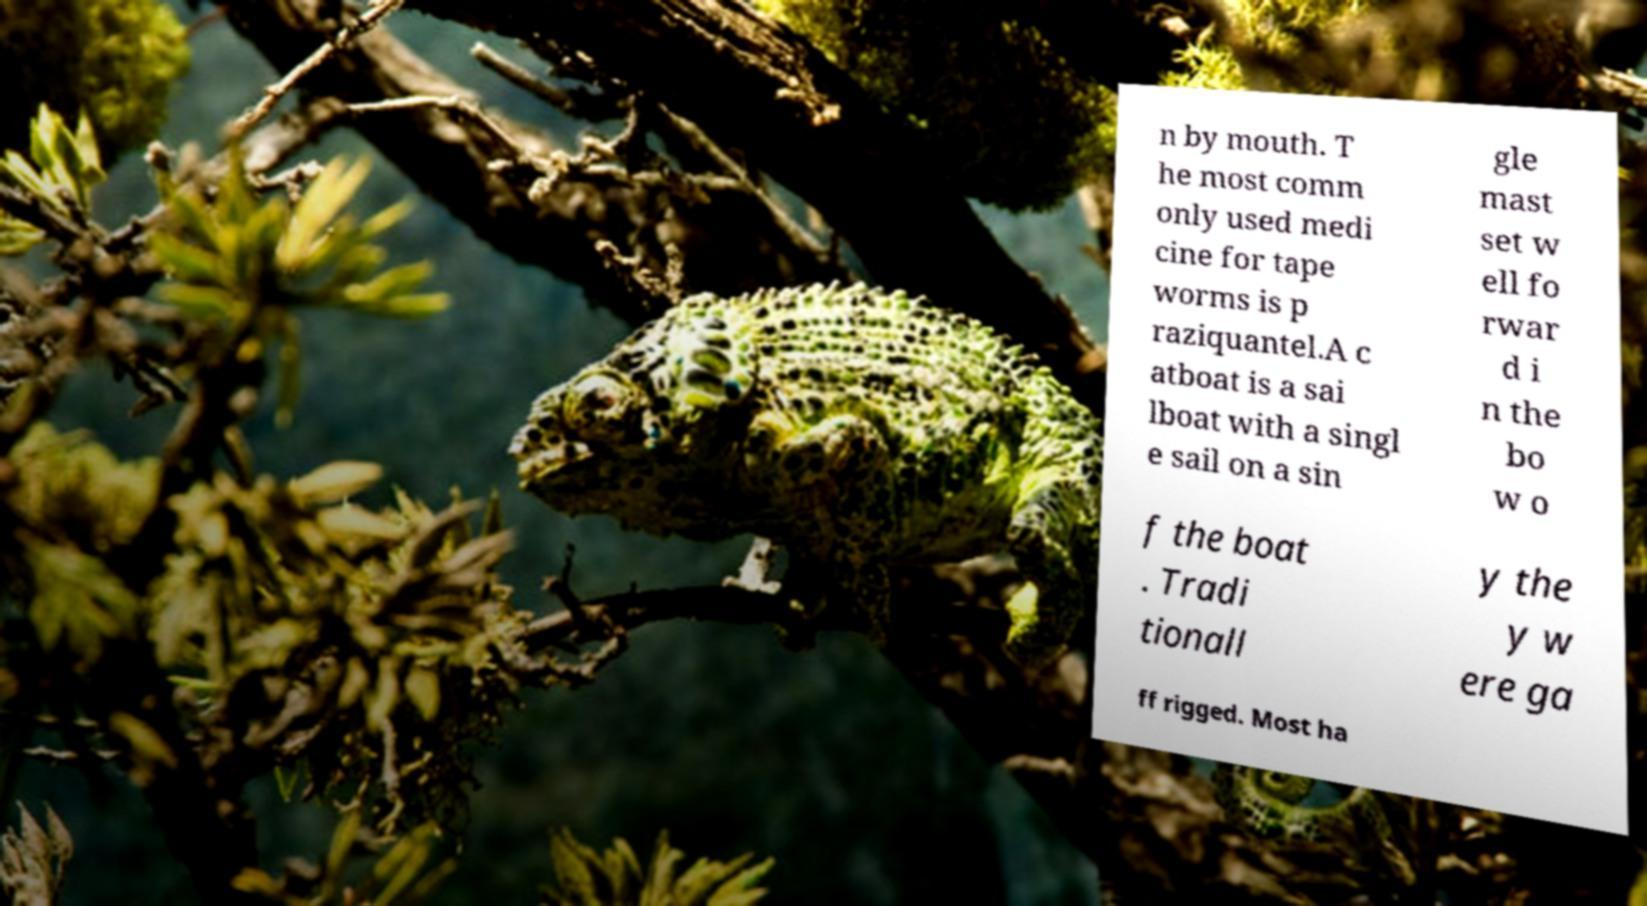For documentation purposes, I need the text within this image transcribed. Could you provide that? n by mouth. T he most comm only used medi cine for tape worms is p raziquantel.A c atboat is a sai lboat with a singl e sail on a sin gle mast set w ell fo rwar d i n the bo w o f the boat . Tradi tionall y the y w ere ga ff rigged. Most ha 